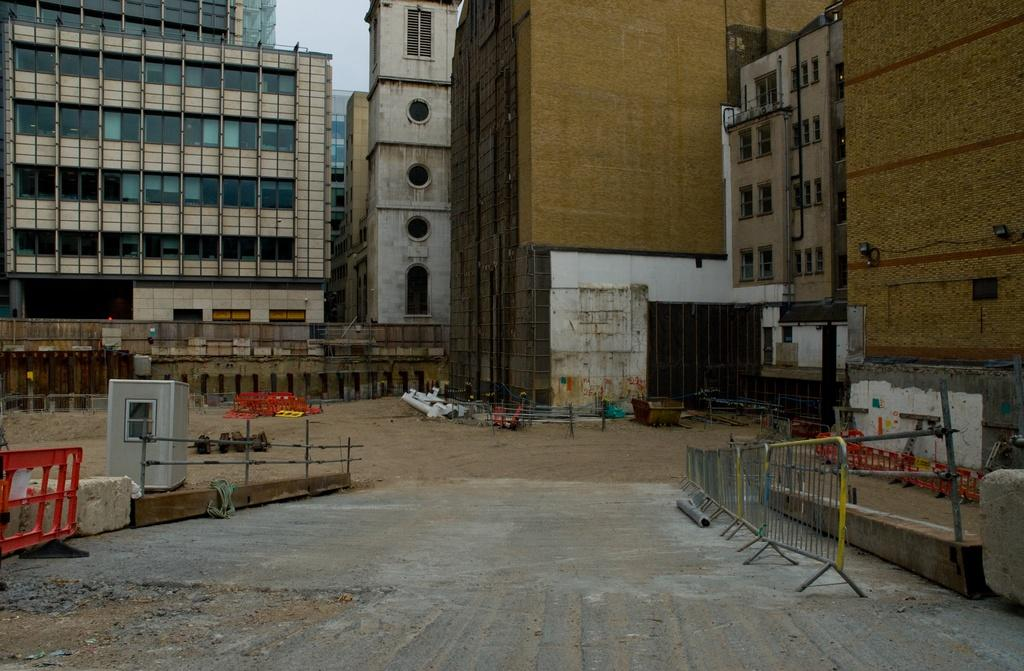What type of structures can be seen in the image? There are buildings in the image. What is located in the foreground of the image? There are railings in the foreground of the image. What can be seen illuminating the scene in the image? There are lights in the image. What is attached to the wall in the image? There is a pipe on the wall in the image. What is visible at the top of the image? The sky is visible at the top of the image. What type of terrain is present at the bottom of the image? Mud is present at the bottom of the image. What type of love is expressed by the thunder in the image? There is no thunder present in the image, and therefore no expression of love can be observed. What is the desire of the pipe on the wall in the image? The pipe on the wall is an inanimate object and does not have desires. 